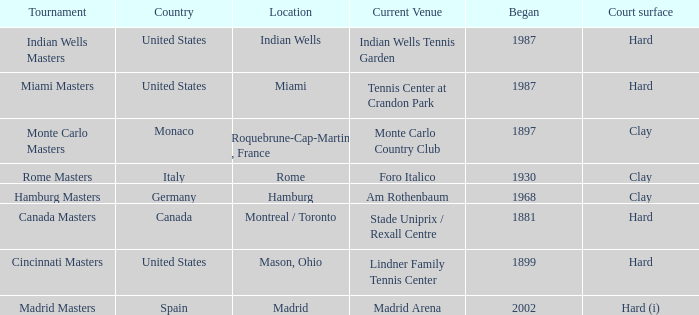What tournaments have their current location at the madrid arena? Madrid Masters. 